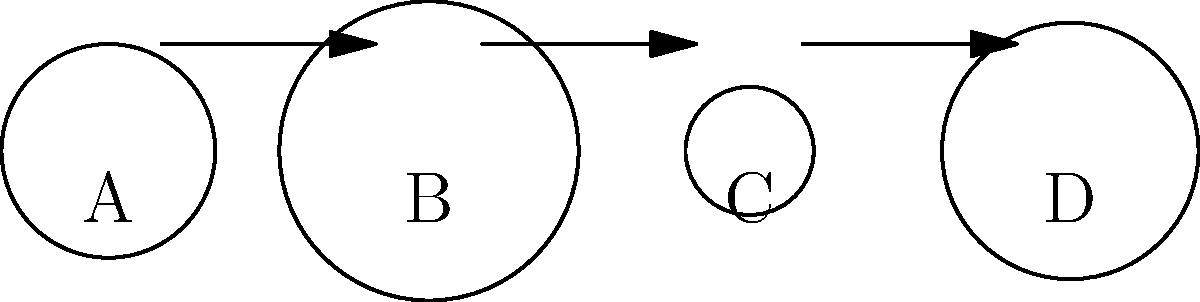As a neonatal nurse, you're teaching a new mother how to assemble a breast pump. Based on the diagram, what is the correct order of assembly for the breast pump components? To determine the correct assembly sequence for the breast pump, we need to analyze the components and their logical order of assembly:

1. Component A represents the base or motor unit of the breast pump. This is typically the starting point for assembly.

2. Component B is the breast shield or flange, which directly contacts the breast. This should be attached to the base next.

3. Component C appears to be a connector or valve, which regulates the flow of milk. This would logically connect to the breast shield.

4. Component D is clearly the collection bottle, which should be attached last to collect the expressed milk.

The arrows in the diagram also indicate the correct order of assembly, moving from left to right.

Therefore, the correct assembly sequence is:

A (base) → B (breast shield/flange) → C (connector/valve) → D (collection bottle)
Answer: A-B-C-D 